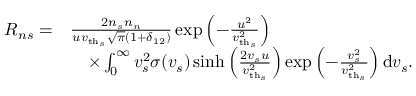<formula> <loc_0><loc_0><loc_500><loc_500>\begin{array} { r l } { R _ { n s } = } & { \frac { 2 n _ { s } n _ { n } } { u { v _ { t h _ { s } } } \sqrt { \pi } ( 1 + \delta _ { 1 2 } ) } \exp \left ( - \frac { u ^ { 2 } } { { v _ { t h _ { s } } } ^ { 2 } } \right ) } \\ & { \quad \times \int _ { 0 } ^ { \infty } v _ { s } ^ { 2 } \sigma ( v _ { s } ) \sinh \left ( \frac { 2 v _ { s } u } { { v _ { t h _ { s } } } ^ { 2 } } \right ) \exp \left ( - \frac { v _ { s } ^ { 2 } } { { v _ { t h _ { s } } } ^ { 2 } } \right ) d v _ { s } . } \end{array}</formula> 